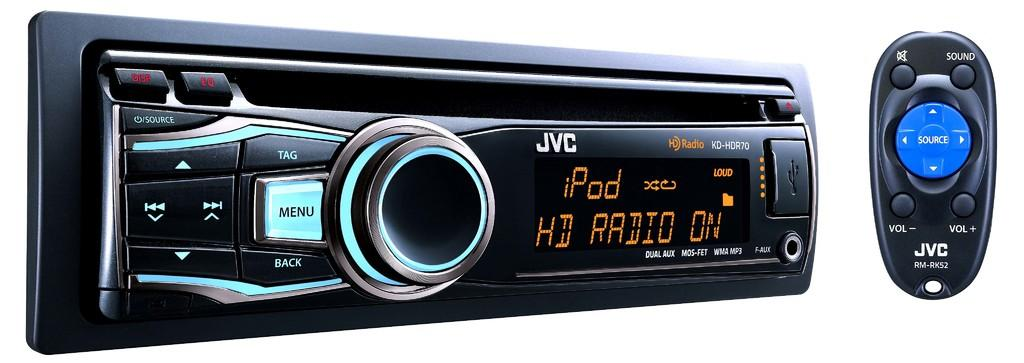<image>
Present a compact description of the photo's key features. JVC radio is connected to the iPod and can be used with a remote. 